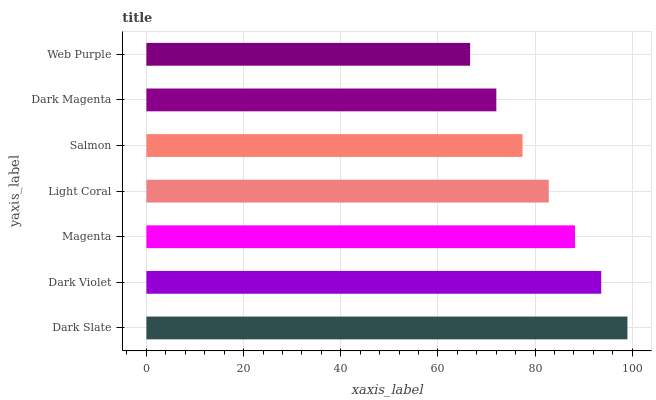Is Web Purple the minimum?
Answer yes or no. Yes. Is Dark Slate the maximum?
Answer yes or no. Yes. Is Dark Violet the minimum?
Answer yes or no. No. Is Dark Violet the maximum?
Answer yes or no. No. Is Dark Slate greater than Dark Violet?
Answer yes or no. Yes. Is Dark Violet less than Dark Slate?
Answer yes or no. Yes. Is Dark Violet greater than Dark Slate?
Answer yes or no. No. Is Dark Slate less than Dark Violet?
Answer yes or no. No. Is Light Coral the high median?
Answer yes or no. Yes. Is Light Coral the low median?
Answer yes or no. Yes. Is Salmon the high median?
Answer yes or no. No. Is Salmon the low median?
Answer yes or no. No. 